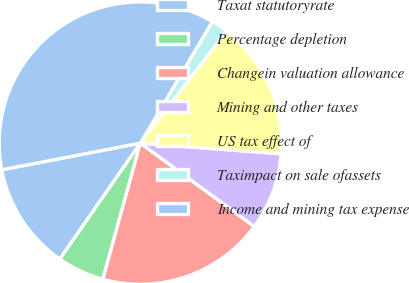<chart> <loc_0><loc_0><loc_500><loc_500><pie_chart><fcel>Taxat statutoryrate<fcel>Percentage depletion<fcel>Changein valuation allowance<fcel>Mining and other taxes<fcel>US tax effect of<fcel>Taximpact on sale ofassets<fcel>Income and mining tax expense<nl><fcel>12.31%<fcel>5.38%<fcel>19.23%<fcel>8.85%<fcel>15.77%<fcel>1.92%<fcel>36.54%<nl></chart> 